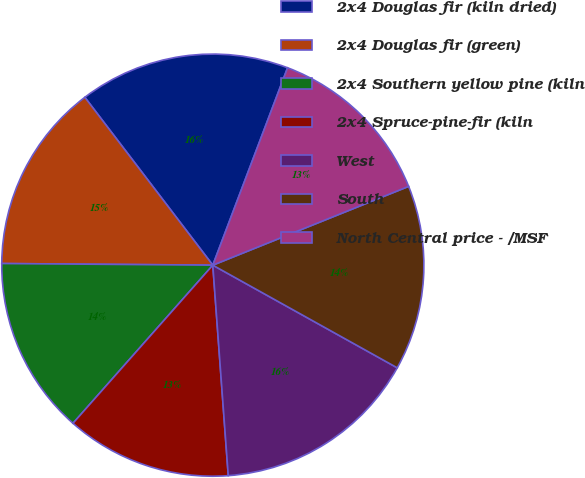<chart> <loc_0><loc_0><loc_500><loc_500><pie_chart><fcel>2x4 Douglas fir (kiln dried)<fcel>2x4 Douglas fir (green)<fcel>2x4 Southern yellow pine (kiln<fcel>2x4 Spruce-pine-fir (kiln<fcel>West<fcel>South<fcel>North Central price - /MSF<nl><fcel>16.13%<fcel>14.51%<fcel>13.6%<fcel>12.69%<fcel>15.75%<fcel>14.17%<fcel>13.15%<nl></chart> 